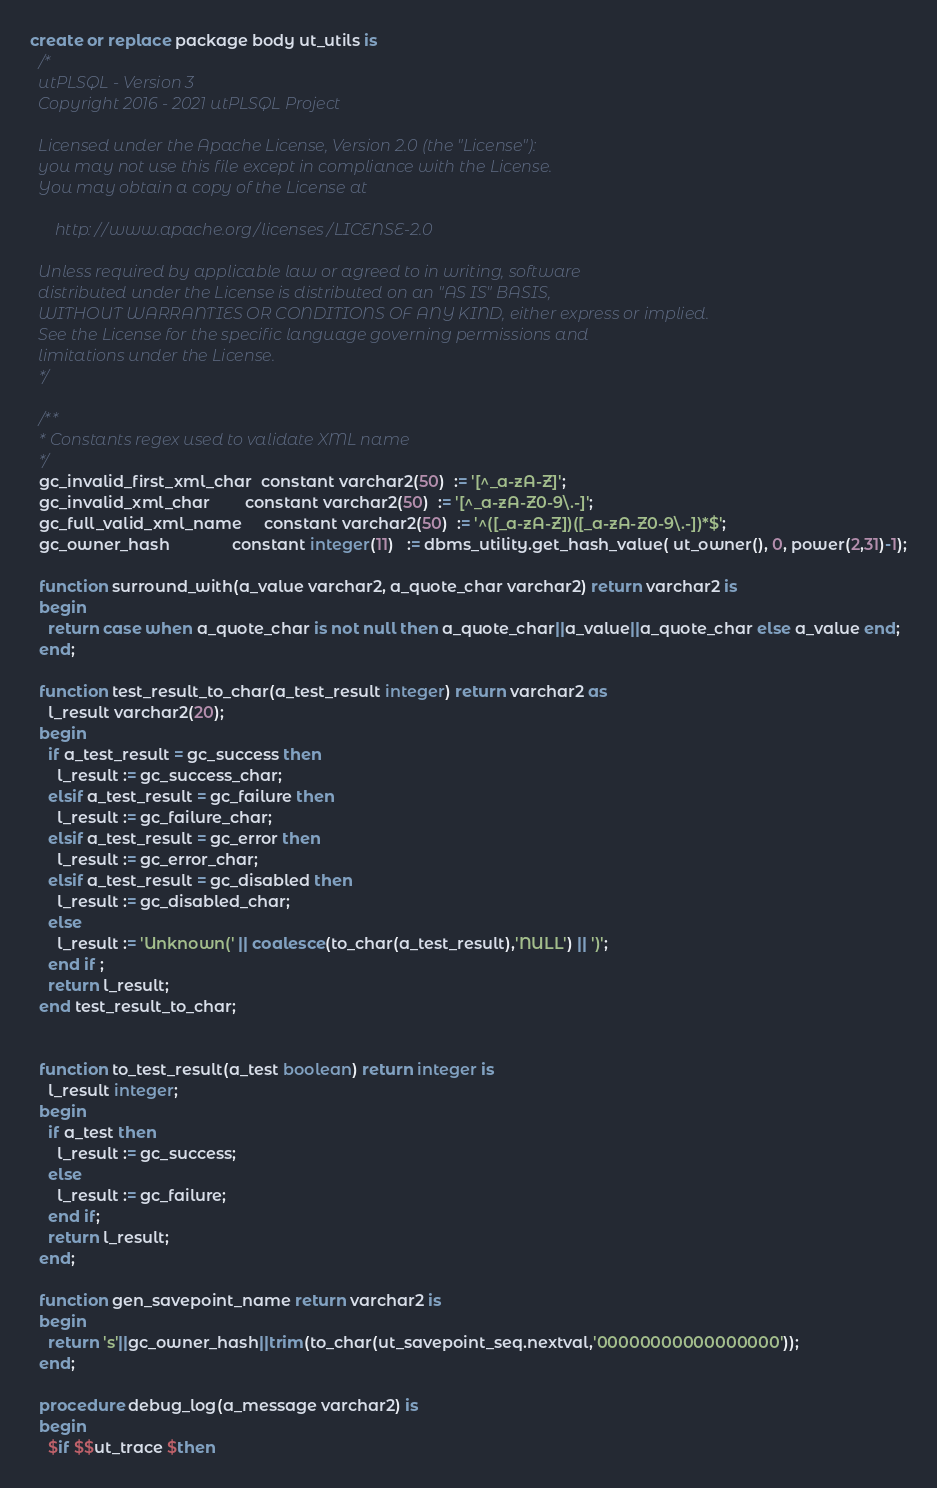Convert code to text. <code><loc_0><loc_0><loc_500><loc_500><_SQL_>create or replace package body ut_utils is
  /*
  utPLSQL - Version 3
  Copyright 2016 - 2021 utPLSQL Project

  Licensed under the Apache License, Version 2.0 (the "License"):
  you may not use this file except in compliance with the License.
  You may obtain a copy of the License at

      http://www.apache.org/licenses/LICENSE-2.0

  Unless required by applicable law or agreed to in writing, software
  distributed under the License is distributed on an "AS IS" BASIS,
  WITHOUT WARRANTIES OR CONDITIONS OF ANY KIND, either express or implied.
  See the License for the specific language governing permissions and
  limitations under the License.
  */

  /**
  * Constants regex used to validate XML name
  */
  gc_invalid_first_xml_char  constant varchar2(50)  := '[^_a-zA-Z]';
  gc_invalid_xml_char        constant varchar2(50)  := '[^_a-zA-Z0-9\.-]';
  gc_full_valid_xml_name     constant varchar2(50)  := '^([_a-zA-Z])([_a-zA-Z0-9\.-])*$';
  gc_owner_hash              constant integer(11)   := dbms_utility.get_hash_value( ut_owner(), 0, power(2,31)-1);

  function surround_with(a_value varchar2, a_quote_char varchar2) return varchar2 is
  begin
    return case when a_quote_char is not null then a_quote_char||a_value||a_quote_char else a_value end;
  end;

  function test_result_to_char(a_test_result integer) return varchar2 as
    l_result varchar2(20);
  begin
    if a_test_result = gc_success then
      l_result := gc_success_char;
    elsif a_test_result = gc_failure then
      l_result := gc_failure_char;
    elsif a_test_result = gc_error then
      l_result := gc_error_char;
    elsif a_test_result = gc_disabled then
      l_result := gc_disabled_char;
    else
      l_result := 'Unknown(' || coalesce(to_char(a_test_result),'NULL') || ')';
    end if ;
    return l_result;
  end test_result_to_char;


  function to_test_result(a_test boolean) return integer is
    l_result integer;
  begin
    if a_test then
      l_result := gc_success;
    else
      l_result := gc_failure;
    end if;
    return l_result;
  end;

  function gen_savepoint_name return varchar2 is
  begin
    return 's'||gc_owner_hash||trim(to_char(ut_savepoint_seq.nextval,'00000000000000000'));
  end;

  procedure debug_log(a_message varchar2) is
  begin
    $if $$ut_trace $then</code> 